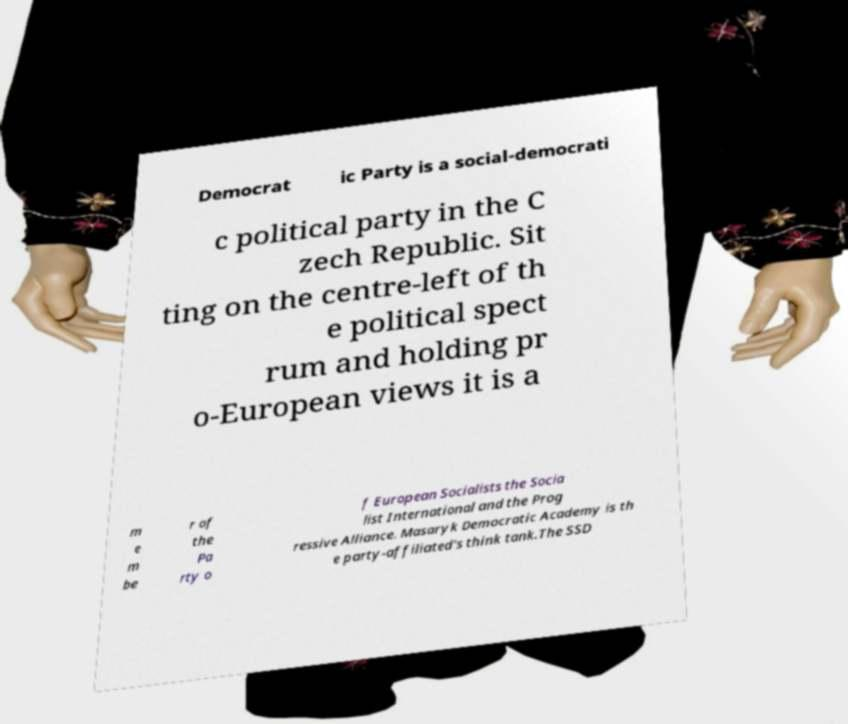Please read and relay the text visible in this image. What does it say? Democrat ic Party is a social-democrati c political party in the C zech Republic. Sit ting on the centre-left of th e political spect rum and holding pr o-European views it is a m e m be r of the Pa rty o f European Socialists the Socia list International and the Prog ressive Alliance. Masaryk Democratic Academy is th e party-affiliated's think tank.The SSD 